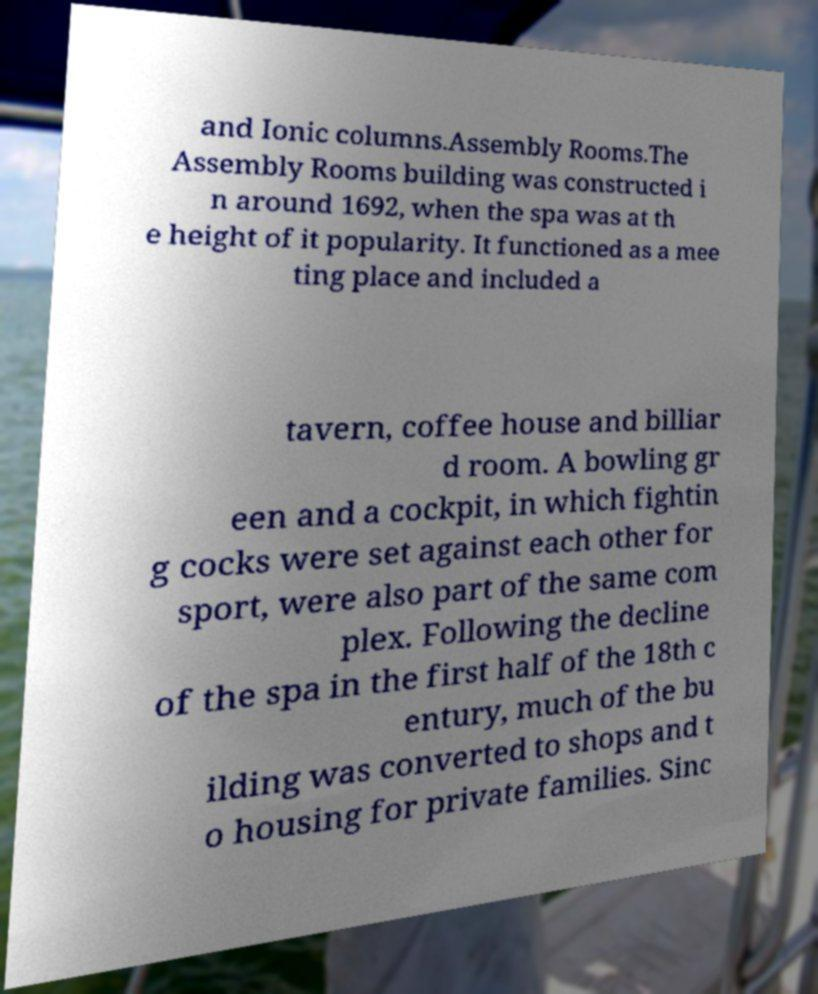Please read and relay the text visible in this image. What does it say? and Ionic columns.Assembly Rooms.The Assembly Rooms building was constructed i n around 1692, when the spa was at th e height of it popularity. It functioned as a mee ting place and included a tavern, coffee house and billiar d room. A bowling gr een and a cockpit, in which fightin g cocks were set against each other for sport, were also part of the same com plex. Following the decline of the spa in the first half of the 18th c entury, much of the bu ilding was converted to shops and t o housing for private families. Sinc 